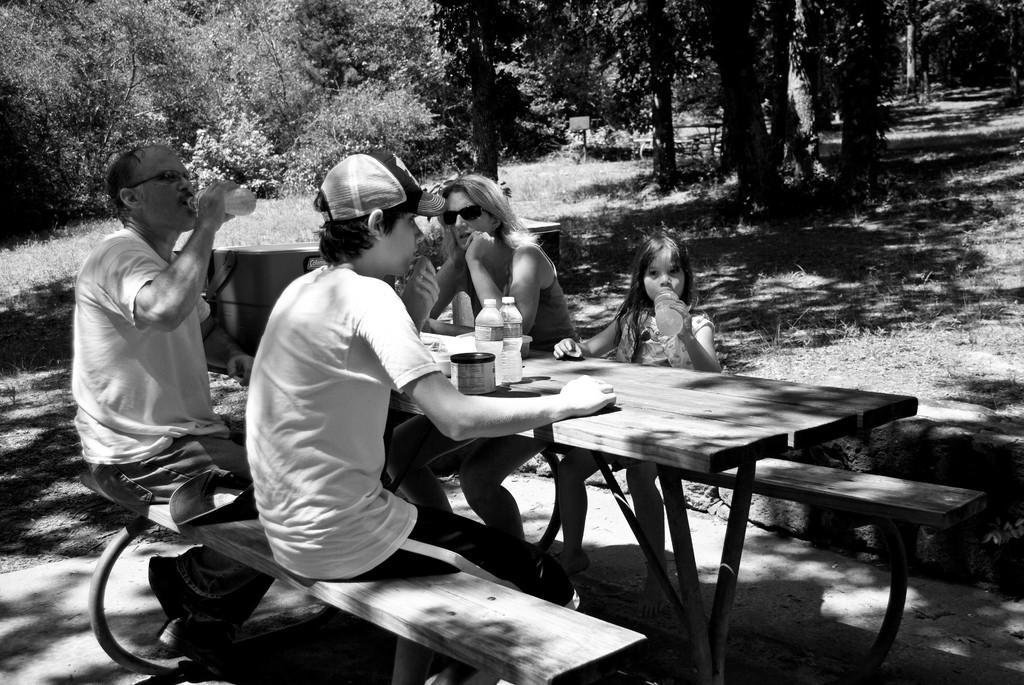In one or two sentences, can you explain what this image depicts? In this image I can see some people are sitting. I can see objects on the table. In the background, I can see the trees. I can see the grass. 